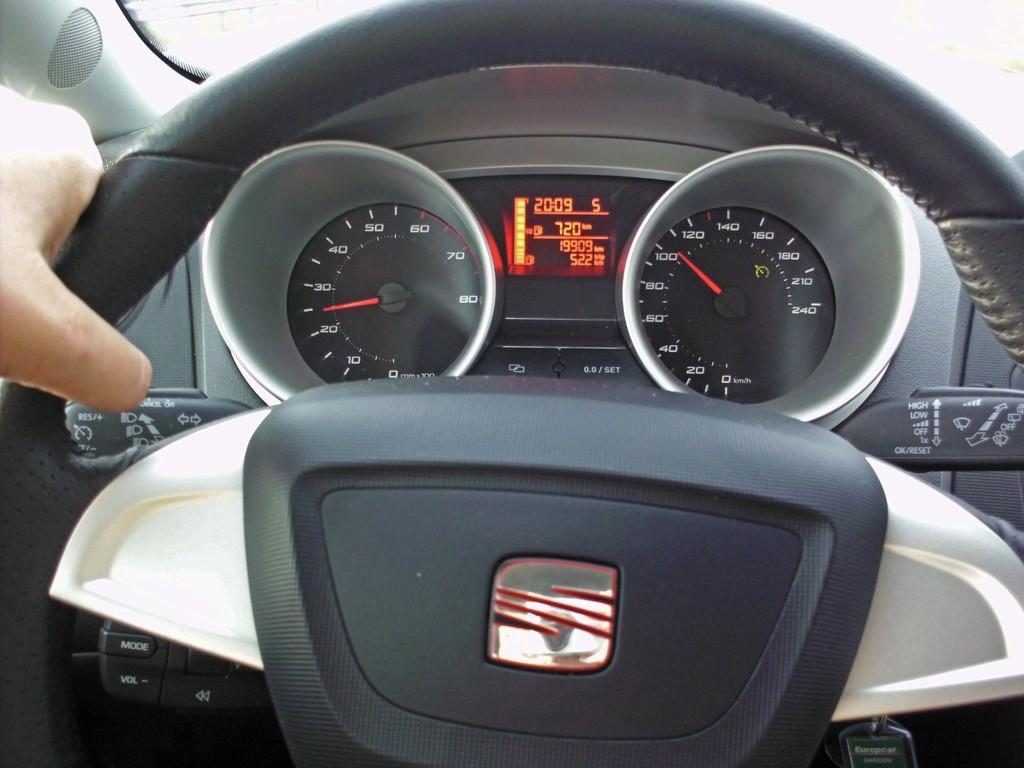What is the person's hand doing in the image? The person's hand is on the steering wheel of a vehicle in the image. What instrument is visible in the vehicle's dashboard? The speedometer of the vehicle is visible in the image. What colors are present on the speedometer? The speedometer has colors: grey, black, orange, and red. What type of gun is being used to power the vehicle in the image? There is no gun present in the image, and vehicles are not powered by guns. 